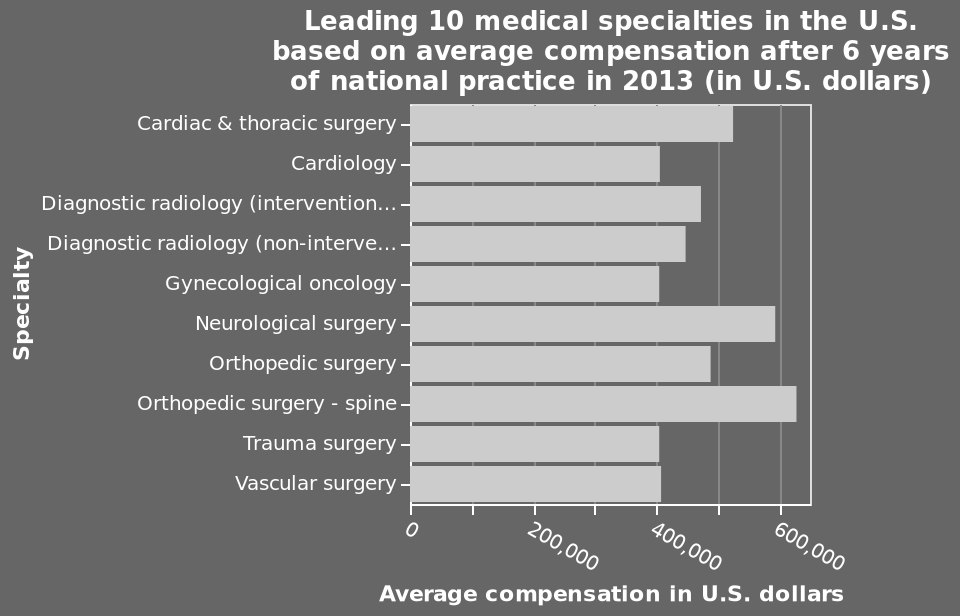<image>
Which specialization has the highest compensation?  Orthopaedic surgery (spine) has the highest compensation. What does the bar chart show? The bar chart shows the top 10 medical specialties in the U.S. based on average compensation after 6 years of national practice in 2013. What was the year in which the average compensation data was collected? The average compensation data was collected in the year 2013. 